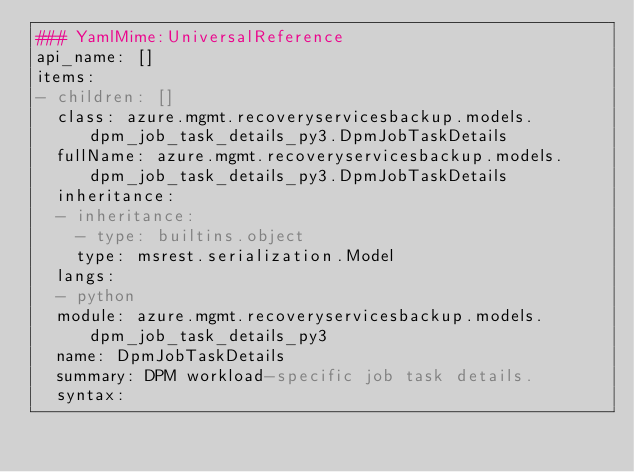<code> <loc_0><loc_0><loc_500><loc_500><_YAML_>### YamlMime:UniversalReference
api_name: []
items:
- children: []
  class: azure.mgmt.recoveryservicesbackup.models.dpm_job_task_details_py3.DpmJobTaskDetails
  fullName: azure.mgmt.recoveryservicesbackup.models.dpm_job_task_details_py3.DpmJobTaskDetails
  inheritance:
  - inheritance:
    - type: builtins.object
    type: msrest.serialization.Model
  langs:
  - python
  module: azure.mgmt.recoveryservicesbackup.models.dpm_job_task_details_py3
  name: DpmJobTaskDetails
  summary: DPM workload-specific job task details.
  syntax:</code> 